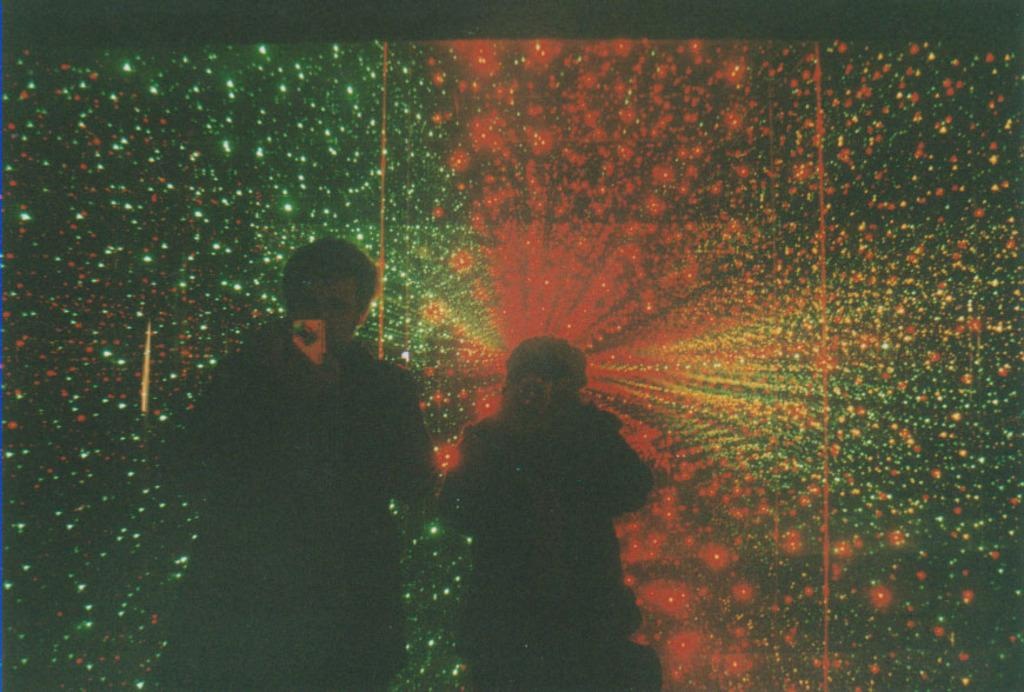How many people are in the image? There are persons in the image, but the exact number is not specified. What can be seen in addition to the persons in the image? There are lights in the image. What type of hat is the dog wearing in the image? There is no dog or hat present in the image. 